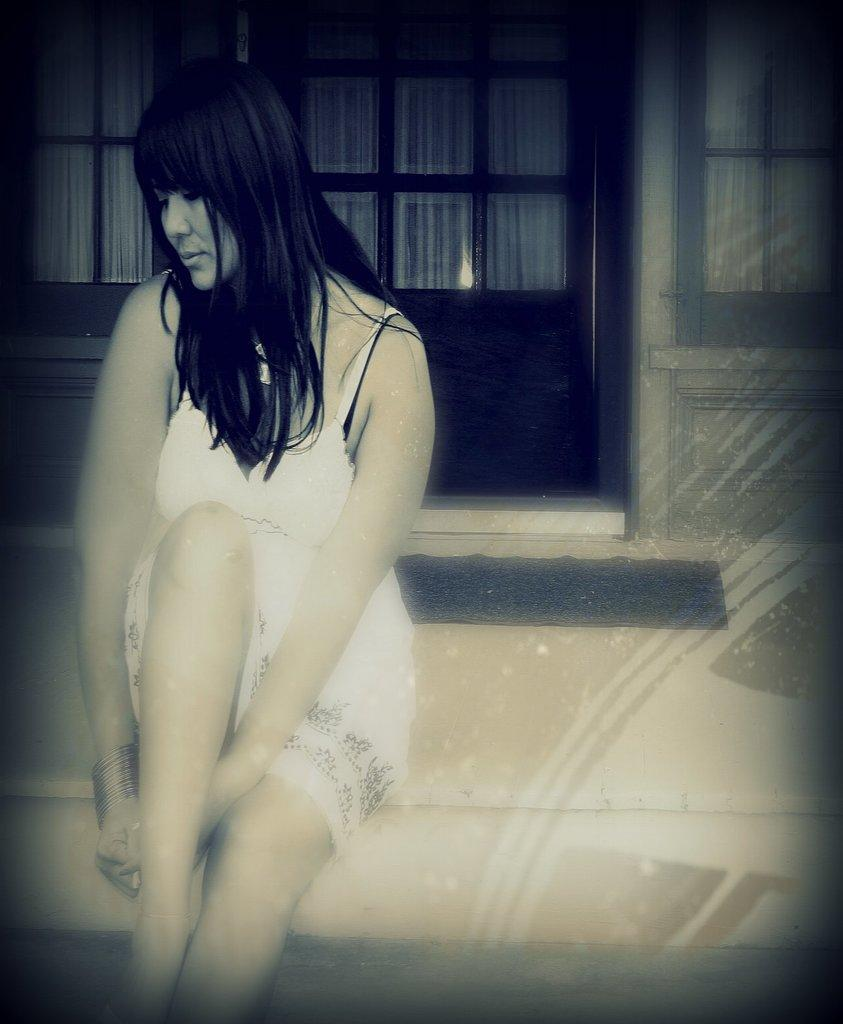What is the lady in the image doing? The lady is sitting in the image. What can be seen in the background of the image? There is a door in the background of the image. What is placed near the door in the image? There is a doormat in the image. How many toes can be seen on the hen in the image? There is no hen present in the image, so the number of toes cannot be determined. 